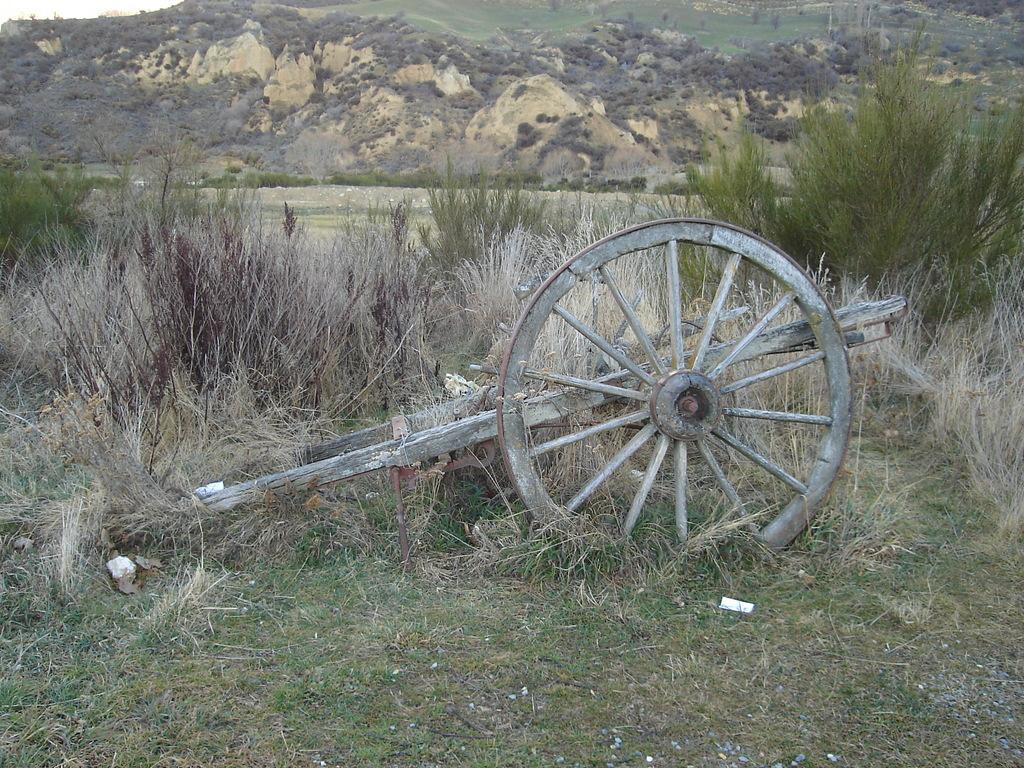Can you describe this image briefly? In this image I see a cart over here and I see the grass and the plants. In the background I see the mountains. 